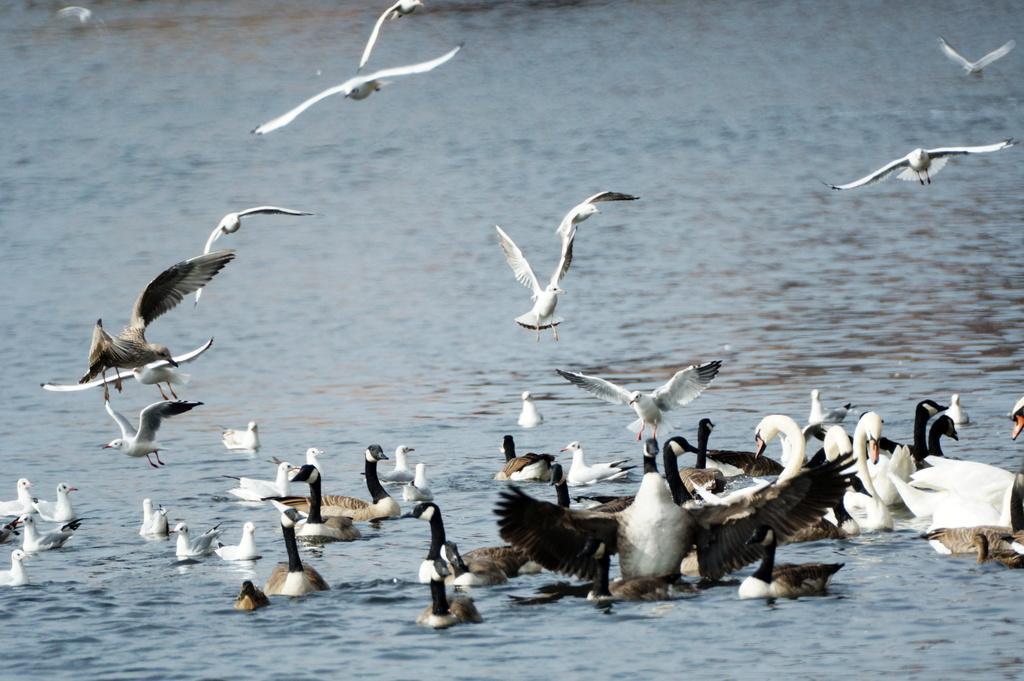Can you describe this image briefly? This image consists of water. In that there are so many swans and ducks. Some are flying. 